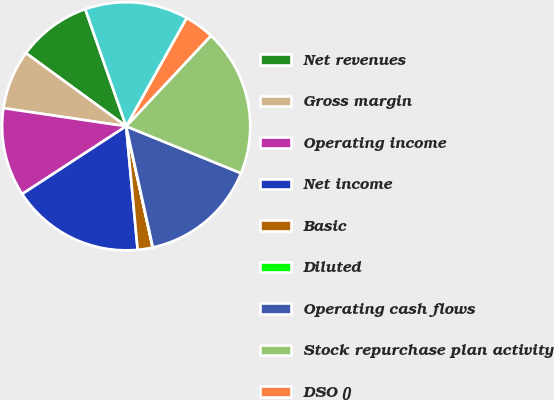Convert chart. <chart><loc_0><loc_0><loc_500><loc_500><pie_chart><fcel>Net revenues<fcel>Gross margin<fcel>Operating income<fcel>Net income<fcel>Basic<fcel>Diluted<fcel>Operating cash flows<fcel>Stock repurchase plan activity<fcel>DSO ()<fcel>Deferred revenue<nl><fcel>9.62%<fcel>7.7%<fcel>11.53%<fcel>17.28%<fcel>1.95%<fcel>0.03%<fcel>15.37%<fcel>19.2%<fcel>3.87%<fcel>13.45%<nl></chart> 